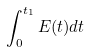<formula> <loc_0><loc_0><loc_500><loc_500>\int _ { 0 } ^ { t _ { 1 } } E ( t ) d t</formula> 